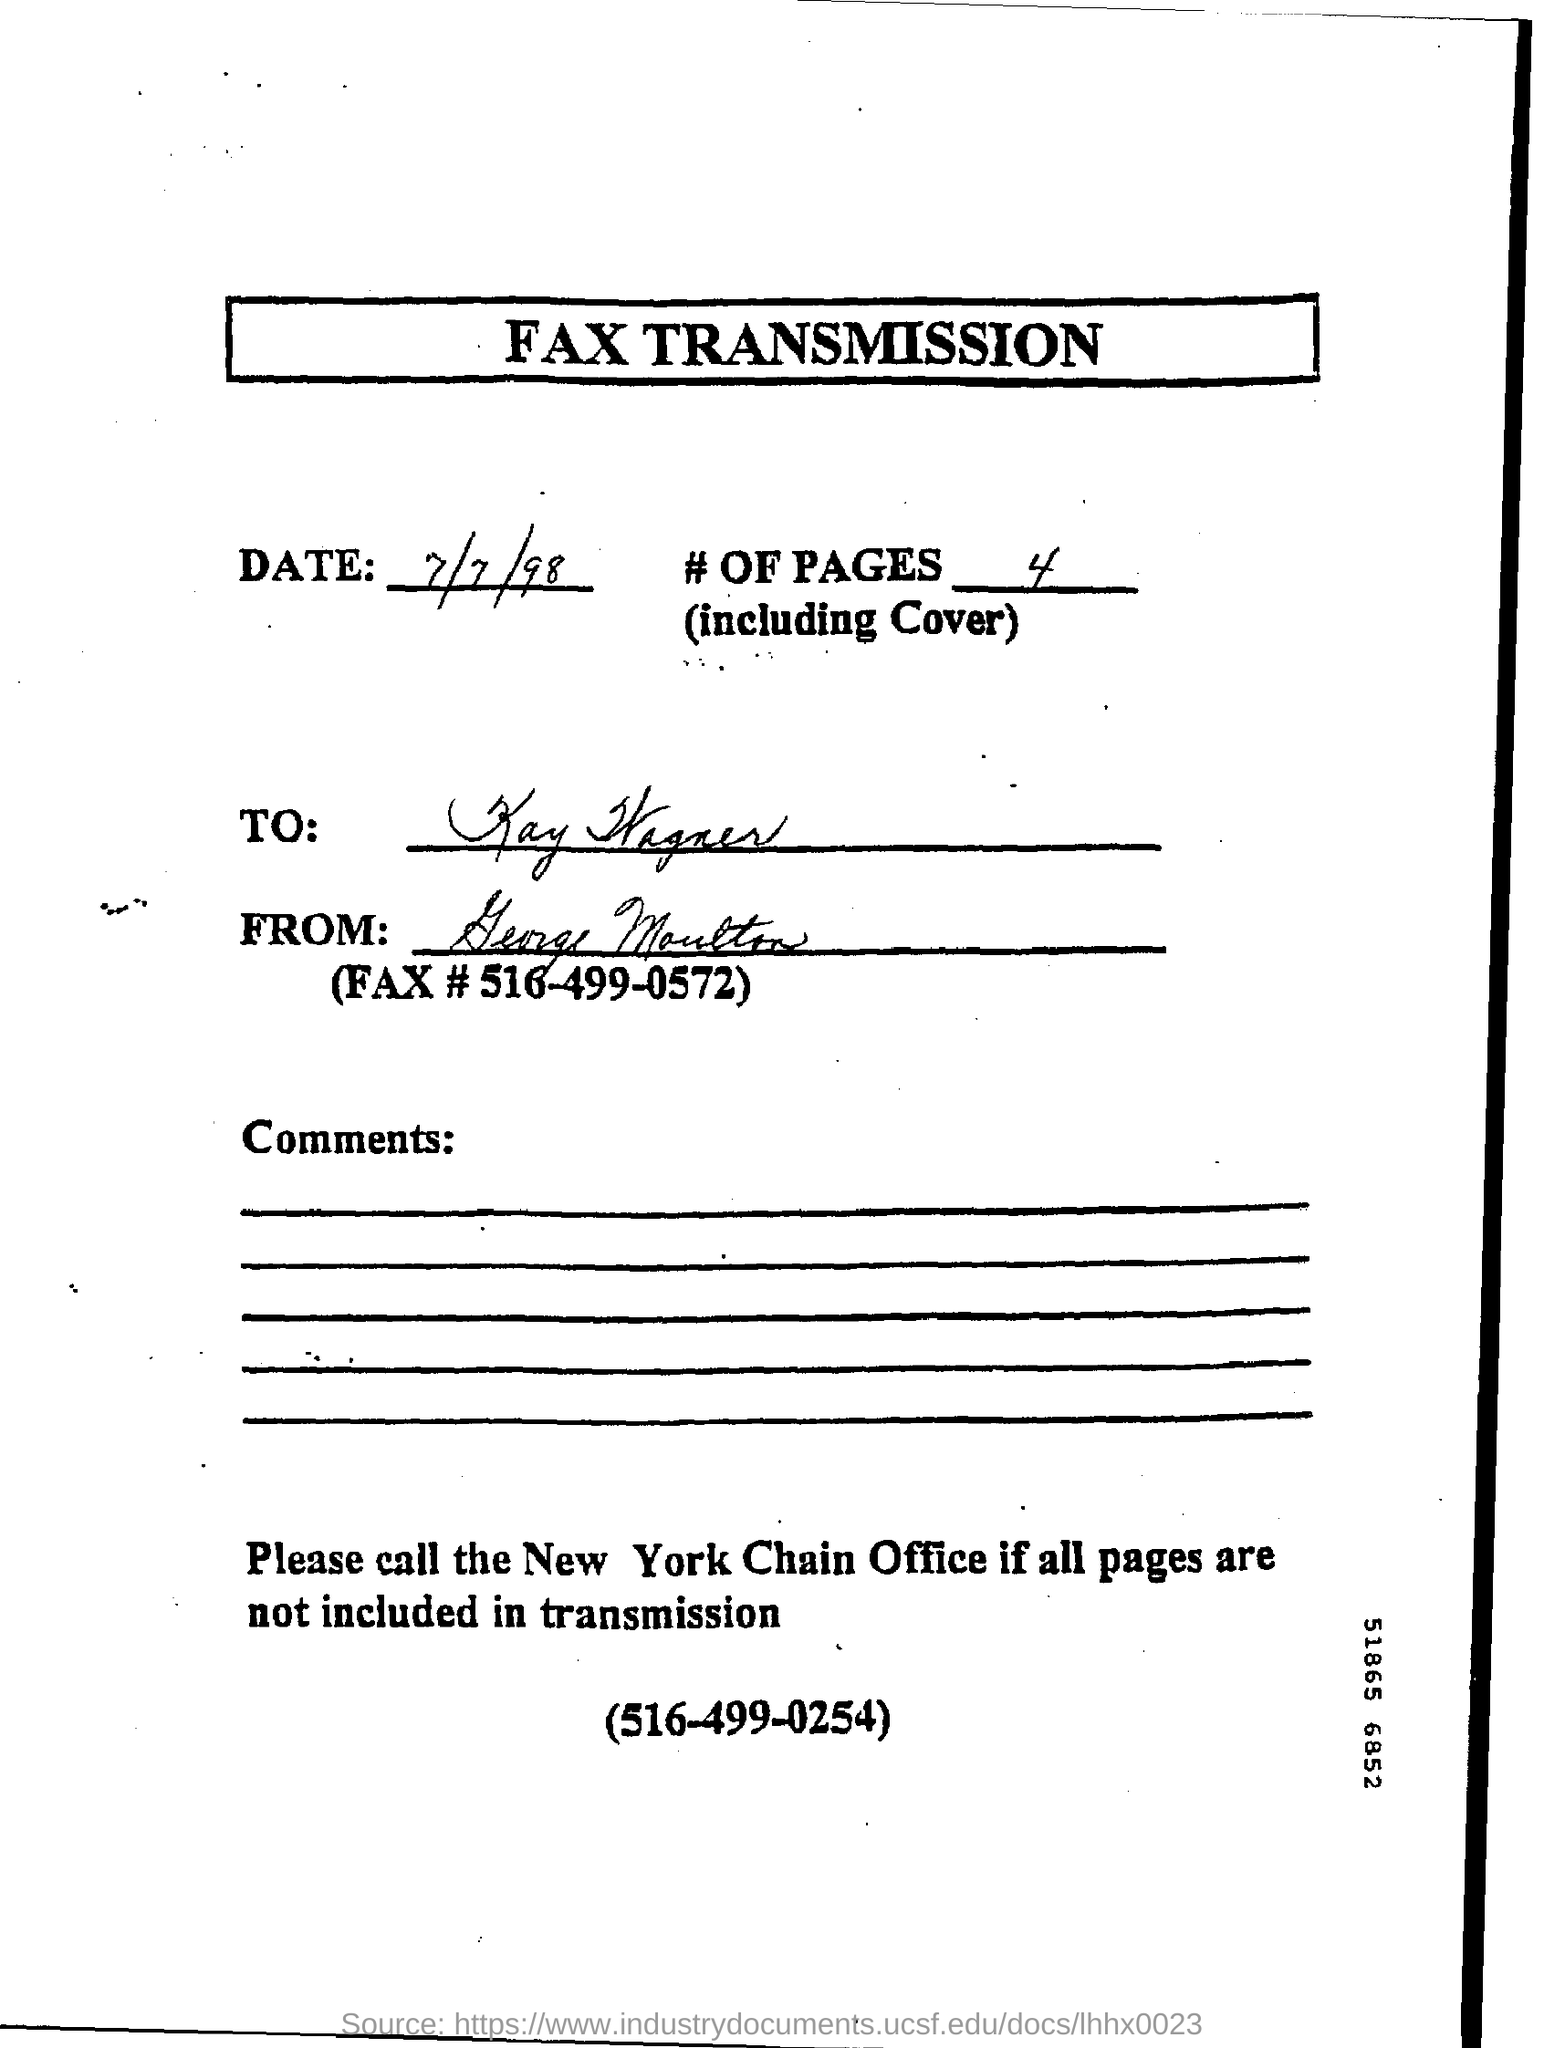What is the date mentioned in the letter?
Offer a very short reply. 7/7/98. What is the to address?
Make the answer very short. Kay wagner. What is the fax number?
Your answer should be very brief. (516-499-0572). 